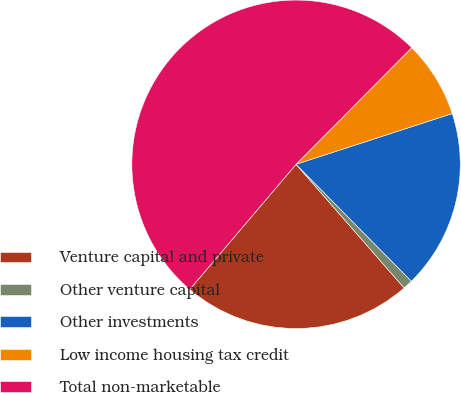Convert chart to OTSL. <chart><loc_0><loc_0><loc_500><loc_500><pie_chart><fcel>Venture capital and private<fcel>Other venture capital<fcel>Other investments<fcel>Low income housing tax credit<fcel>Total non-marketable<nl><fcel>22.64%<fcel>0.96%<fcel>17.61%<fcel>7.56%<fcel>51.22%<nl></chart> 